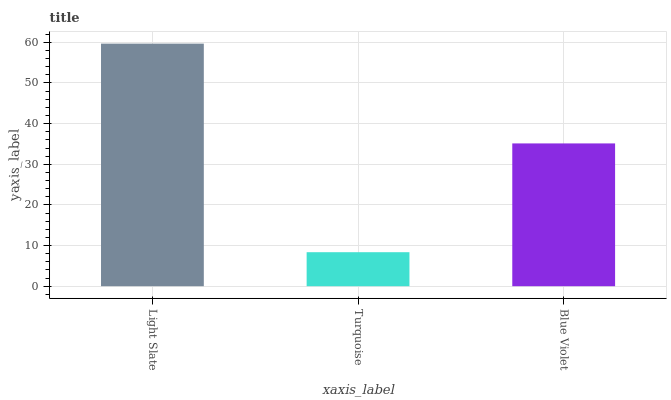Is Blue Violet the minimum?
Answer yes or no. No. Is Blue Violet the maximum?
Answer yes or no. No. Is Blue Violet greater than Turquoise?
Answer yes or no. Yes. Is Turquoise less than Blue Violet?
Answer yes or no. Yes. Is Turquoise greater than Blue Violet?
Answer yes or no. No. Is Blue Violet less than Turquoise?
Answer yes or no. No. Is Blue Violet the high median?
Answer yes or no. Yes. Is Blue Violet the low median?
Answer yes or no. Yes. Is Light Slate the high median?
Answer yes or no. No. Is Turquoise the low median?
Answer yes or no. No. 